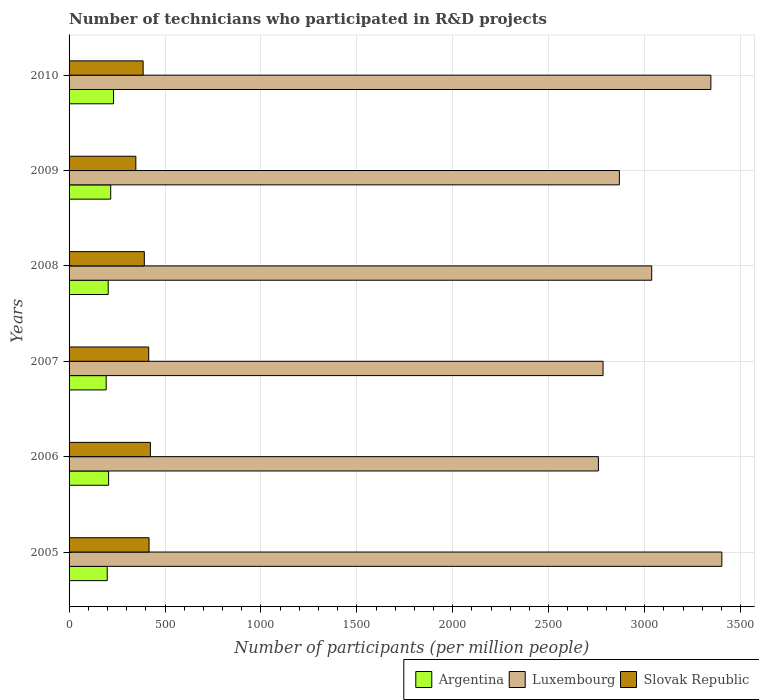How many different coloured bars are there?
Your answer should be compact. 3. Are the number of bars per tick equal to the number of legend labels?
Make the answer very short. Yes. Are the number of bars on each tick of the Y-axis equal?
Make the answer very short. Yes. How many bars are there on the 5th tick from the bottom?
Offer a very short reply. 3. What is the label of the 4th group of bars from the top?
Your response must be concise. 2007. In how many cases, is the number of bars for a given year not equal to the number of legend labels?
Provide a short and direct response. 0. What is the number of technicians who participated in R&D projects in Luxembourg in 2005?
Keep it short and to the point. 3402.45. Across all years, what is the maximum number of technicians who participated in R&D projects in Slovak Republic?
Offer a very short reply. 423.83. Across all years, what is the minimum number of technicians who participated in R&D projects in Argentina?
Give a very brief answer. 193.45. What is the total number of technicians who participated in R&D projects in Argentina in the graph?
Keep it short and to the point. 1250.98. What is the difference between the number of technicians who participated in R&D projects in Slovak Republic in 2005 and that in 2007?
Your answer should be very brief. 1.79. What is the difference between the number of technicians who participated in R&D projects in Argentina in 2005 and the number of technicians who participated in R&D projects in Luxembourg in 2007?
Ensure brevity in your answer.  -2584.25. What is the average number of technicians who participated in R&D projects in Luxembourg per year?
Ensure brevity in your answer.  3032.48. In the year 2009, what is the difference between the number of technicians who participated in R&D projects in Slovak Republic and number of technicians who participated in R&D projects in Argentina?
Ensure brevity in your answer.  131.09. In how many years, is the number of technicians who participated in R&D projects in Slovak Republic greater than 1500 ?
Your answer should be compact. 0. What is the ratio of the number of technicians who participated in R&D projects in Slovak Republic in 2005 to that in 2009?
Make the answer very short. 1.2. Is the difference between the number of technicians who participated in R&D projects in Slovak Republic in 2005 and 2009 greater than the difference between the number of technicians who participated in R&D projects in Argentina in 2005 and 2009?
Offer a very short reply. Yes. What is the difference between the highest and the second highest number of technicians who participated in R&D projects in Luxembourg?
Keep it short and to the point. 57.23. What is the difference between the highest and the lowest number of technicians who participated in R&D projects in Slovak Republic?
Your answer should be very brief. 75.77. What does the 1st bar from the top in 2006 represents?
Your response must be concise. Slovak Republic. What does the 1st bar from the bottom in 2007 represents?
Provide a succinct answer. Argentina. Are all the bars in the graph horizontal?
Keep it short and to the point. Yes. What is the difference between two consecutive major ticks on the X-axis?
Your answer should be very brief. 500. Are the values on the major ticks of X-axis written in scientific E-notation?
Your answer should be very brief. No. Does the graph contain any zero values?
Ensure brevity in your answer.  No. Does the graph contain grids?
Keep it short and to the point. Yes. What is the title of the graph?
Keep it short and to the point. Number of technicians who participated in R&D projects. What is the label or title of the X-axis?
Make the answer very short. Number of participants (per million people). What is the label or title of the Y-axis?
Provide a succinct answer. Years. What is the Number of participants (per million people) in Argentina in 2005?
Provide a succinct answer. 198.95. What is the Number of participants (per million people) in Luxembourg in 2005?
Offer a very short reply. 3402.45. What is the Number of participants (per million people) in Slovak Republic in 2005?
Keep it short and to the point. 416.85. What is the Number of participants (per million people) of Argentina in 2006?
Your response must be concise. 206.05. What is the Number of participants (per million people) of Luxembourg in 2006?
Your answer should be compact. 2758.91. What is the Number of participants (per million people) in Slovak Republic in 2006?
Make the answer very short. 423.83. What is the Number of participants (per million people) in Argentina in 2007?
Your answer should be compact. 193.45. What is the Number of participants (per million people) of Luxembourg in 2007?
Your answer should be compact. 2783.2. What is the Number of participants (per million people) of Slovak Republic in 2007?
Offer a very short reply. 415.06. What is the Number of participants (per million people) of Argentina in 2008?
Offer a very short reply. 203.95. What is the Number of participants (per million people) in Luxembourg in 2008?
Ensure brevity in your answer.  3036.82. What is the Number of participants (per million people) in Slovak Republic in 2008?
Offer a very short reply. 392.28. What is the Number of participants (per million people) in Argentina in 2009?
Your response must be concise. 216.97. What is the Number of participants (per million people) in Luxembourg in 2009?
Provide a succinct answer. 2868.27. What is the Number of participants (per million people) of Slovak Republic in 2009?
Ensure brevity in your answer.  348.06. What is the Number of participants (per million people) in Argentina in 2010?
Give a very brief answer. 231.62. What is the Number of participants (per million people) in Luxembourg in 2010?
Your response must be concise. 3345.22. What is the Number of participants (per million people) of Slovak Republic in 2010?
Your answer should be compact. 386.01. Across all years, what is the maximum Number of participants (per million people) in Argentina?
Provide a short and direct response. 231.62. Across all years, what is the maximum Number of participants (per million people) in Luxembourg?
Offer a very short reply. 3402.45. Across all years, what is the maximum Number of participants (per million people) of Slovak Republic?
Offer a very short reply. 423.83. Across all years, what is the minimum Number of participants (per million people) of Argentina?
Ensure brevity in your answer.  193.45. Across all years, what is the minimum Number of participants (per million people) of Luxembourg?
Your response must be concise. 2758.91. Across all years, what is the minimum Number of participants (per million people) of Slovak Republic?
Ensure brevity in your answer.  348.06. What is the total Number of participants (per million people) in Argentina in the graph?
Offer a terse response. 1250.98. What is the total Number of participants (per million people) in Luxembourg in the graph?
Provide a short and direct response. 1.82e+04. What is the total Number of participants (per million people) of Slovak Republic in the graph?
Give a very brief answer. 2382.08. What is the difference between the Number of participants (per million people) in Argentina in 2005 and that in 2006?
Your answer should be compact. -7.1. What is the difference between the Number of participants (per million people) of Luxembourg in 2005 and that in 2006?
Make the answer very short. 643.54. What is the difference between the Number of participants (per million people) in Slovak Republic in 2005 and that in 2006?
Offer a terse response. -6.99. What is the difference between the Number of participants (per million people) in Argentina in 2005 and that in 2007?
Offer a very short reply. 5.5. What is the difference between the Number of participants (per million people) of Luxembourg in 2005 and that in 2007?
Your answer should be very brief. 619.24. What is the difference between the Number of participants (per million people) in Slovak Republic in 2005 and that in 2007?
Ensure brevity in your answer.  1.79. What is the difference between the Number of participants (per million people) of Argentina in 2005 and that in 2008?
Offer a terse response. -5. What is the difference between the Number of participants (per million people) in Luxembourg in 2005 and that in 2008?
Your answer should be compact. 365.62. What is the difference between the Number of participants (per million people) of Slovak Republic in 2005 and that in 2008?
Your answer should be compact. 24.57. What is the difference between the Number of participants (per million people) of Argentina in 2005 and that in 2009?
Provide a short and direct response. -18.02. What is the difference between the Number of participants (per million people) of Luxembourg in 2005 and that in 2009?
Ensure brevity in your answer.  534.17. What is the difference between the Number of participants (per million people) of Slovak Republic in 2005 and that in 2009?
Provide a succinct answer. 68.79. What is the difference between the Number of participants (per million people) in Argentina in 2005 and that in 2010?
Your answer should be compact. -32.67. What is the difference between the Number of participants (per million people) of Luxembourg in 2005 and that in 2010?
Give a very brief answer. 57.23. What is the difference between the Number of participants (per million people) of Slovak Republic in 2005 and that in 2010?
Your answer should be very brief. 30.84. What is the difference between the Number of participants (per million people) in Argentina in 2006 and that in 2007?
Keep it short and to the point. 12.6. What is the difference between the Number of participants (per million people) in Luxembourg in 2006 and that in 2007?
Ensure brevity in your answer.  -24.29. What is the difference between the Number of participants (per million people) of Slovak Republic in 2006 and that in 2007?
Offer a terse response. 8.77. What is the difference between the Number of participants (per million people) in Argentina in 2006 and that in 2008?
Offer a terse response. 2.1. What is the difference between the Number of participants (per million people) of Luxembourg in 2006 and that in 2008?
Give a very brief answer. -277.91. What is the difference between the Number of participants (per million people) of Slovak Republic in 2006 and that in 2008?
Your answer should be compact. 31.56. What is the difference between the Number of participants (per million people) in Argentina in 2006 and that in 2009?
Ensure brevity in your answer.  -10.92. What is the difference between the Number of participants (per million people) in Luxembourg in 2006 and that in 2009?
Offer a terse response. -109.36. What is the difference between the Number of participants (per million people) of Slovak Republic in 2006 and that in 2009?
Keep it short and to the point. 75.77. What is the difference between the Number of participants (per million people) in Argentina in 2006 and that in 2010?
Provide a short and direct response. -25.57. What is the difference between the Number of participants (per million people) of Luxembourg in 2006 and that in 2010?
Make the answer very short. -586.31. What is the difference between the Number of participants (per million people) in Slovak Republic in 2006 and that in 2010?
Ensure brevity in your answer.  37.83. What is the difference between the Number of participants (per million people) of Argentina in 2007 and that in 2008?
Your answer should be compact. -10.51. What is the difference between the Number of participants (per million people) in Luxembourg in 2007 and that in 2008?
Your response must be concise. -253.62. What is the difference between the Number of participants (per million people) of Slovak Republic in 2007 and that in 2008?
Ensure brevity in your answer.  22.79. What is the difference between the Number of participants (per million people) in Argentina in 2007 and that in 2009?
Make the answer very short. -23.52. What is the difference between the Number of participants (per million people) in Luxembourg in 2007 and that in 2009?
Provide a succinct answer. -85.07. What is the difference between the Number of participants (per million people) of Slovak Republic in 2007 and that in 2009?
Make the answer very short. 67. What is the difference between the Number of participants (per million people) of Argentina in 2007 and that in 2010?
Your answer should be very brief. -38.17. What is the difference between the Number of participants (per million people) of Luxembourg in 2007 and that in 2010?
Ensure brevity in your answer.  -562.02. What is the difference between the Number of participants (per million people) of Slovak Republic in 2007 and that in 2010?
Ensure brevity in your answer.  29.05. What is the difference between the Number of participants (per million people) of Argentina in 2008 and that in 2009?
Provide a succinct answer. -13.02. What is the difference between the Number of participants (per million people) in Luxembourg in 2008 and that in 2009?
Provide a short and direct response. 168.55. What is the difference between the Number of participants (per million people) in Slovak Republic in 2008 and that in 2009?
Make the answer very short. 44.22. What is the difference between the Number of participants (per million people) in Argentina in 2008 and that in 2010?
Ensure brevity in your answer.  -27.67. What is the difference between the Number of participants (per million people) of Luxembourg in 2008 and that in 2010?
Ensure brevity in your answer.  -308.39. What is the difference between the Number of participants (per million people) of Slovak Republic in 2008 and that in 2010?
Offer a very short reply. 6.27. What is the difference between the Number of participants (per million people) of Argentina in 2009 and that in 2010?
Ensure brevity in your answer.  -14.65. What is the difference between the Number of participants (per million people) of Luxembourg in 2009 and that in 2010?
Give a very brief answer. -476.95. What is the difference between the Number of participants (per million people) of Slovak Republic in 2009 and that in 2010?
Your answer should be very brief. -37.95. What is the difference between the Number of participants (per million people) of Argentina in 2005 and the Number of participants (per million people) of Luxembourg in 2006?
Keep it short and to the point. -2559.96. What is the difference between the Number of participants (per million people) in Argentina in 2005 and the Number of participants (per million people) in Slovak Republic in 2006?
Ensure brevity in your answer.  -224.88. What is the difference between the Number of participants (per million people) of Luxembourg in 2005 and the Number of participants (per million people) of Slovak Republic in 2006?
Make the answer very short. 2978.61. What is the difference between the Number of participants (per million people) of Argentina in 2005 and the Number of participants (per million people) of Luxembourg in 2007?
Your response must be concise. -2584.25. What is the difference between the Number of participants (per million people) in Argentina in 2005 and the Number of participants (per million people) in Slovak Republic in 2007?
Your answer should be compact. -216.11. What is the difference between the Number of participants (per million people) in Luxembourg in 2005 and the Number of participants (per million people) in Slovak Republic in 2007?
Provide a short and direct response. 2987.38. What is the difference between the Number of participants (per million people) in Argentina in 2005 and the Number of participants (per million people) in Luxembourg in 2008?
Provide a succinct answer. -2837.87. What is the difference between the Number of participants (per million people) in Argentina in 2005 and the Number of participants (per million people) in Slovak Republic in 2008?
Your answer should be compact. -193.33. What is the difference between the Number of participants (per million people) of Luxembourg in 2005 and the Number of participants (per million people) of Slovak Republic in 2008?
Offer a terse response. 3010.17. What is the difference between the Number of participants (per million people) in Argentina in 2005 and the Number of participants (per million people) in Luxembourg in 2009?
Make the answer very short. -2669.32. What is the difference between the Number of participants (per million people) of Argentina in 2005 and the Number of participants (per million people) of Slovak Republic in 2009?
Keep it short and to the point. -149.11. What is the difference between the Number of participants (per million people) in Luxembourg in 2005 and the Number of participants (per million people) in Slovak Republic in 2009?
Provide a succinct answer. 3054.39. What is the difference between the Number of participants (per million people) in Argentina in 2005 and the Number of participants (per million people) in Luxembourg in 2010?
Your answer should be very brief. -3146.27. What is the difference between the Number of participants (per million people) in Argentina in 2005 and the Number of participants (per million people) in Slovak Republic in 2010?
Offer a very short reply. -187.06. What is the difference between the Number of participants (per million people) of Luxembourg in 2005 and the Number of participants (per million people) of Slovak Republic in 2010?
Ensure brevity in your answer.  3016.44. What is the difference between the Number of participants (per million people) in Argentina in 2006 and the Number of participants (per million people) in Luxembourg in 2007?
Provide a short and direct response. -2577.15. What is the difference between the Number of participants (per million people) of Argentina in 2006 and the Number of participants (per million people) of Slovak Republic in 2007?
Provide a succinct answer. -209.01. What is the difference between the Number of participants (per million people) of Luxembourg in 2006 and the Number of participants (per million people) of Slovak Republic in 2007?
Ensure brevity in your answer.  2343.85. What is the difference between the Number of participants (per million people) of Argentina in 2006 and the Number of participants (per million people) of Luxembourg in 2008?
Your response must be concise. -2830.78. What is the difference between the Number of participants (per million people) in Argentina in 2006 and the Number of participants (per million people) in Slovak Republic in 2008?
Provide a succinct answer. -186.23. What is the difference between the Number of participants (per million people) of Luxembourg in 2006 and the Number of participants (per million people) of Slovak Republic in 2008?
Make the answer very short. 2366.64. What is the difference between the Number of participants (per million people) in Argentina in 2006 and the Number of participants (per million people) in Luxembourg in 2009?
Offer a terse response. -2662.22. What is the difference between the Number of participants (per million people) in Argentina in 2006 and the Number of participants (per million people) in Slovak Republic in 2009?
Your response must be concise. -142.01. What is the difference between the Number of participants (per million people) in Luxembourg in 2006 and the Number of participants (per million people) in Slovak Republic in 2009?
Give a very brief answer. 2410.85. What is the difference between the Number of participants (per million people) of Argentina in 2006 and the Number of participants (per million people) of Luxembourg in 2010?
Your answer should be compact. -3139.17. What is the difference between the Number of participants (per million people) of Argentina in 2006 and the Number of participants (per million people) of Slovak Republic in 2010?
Your answer should be compact. -179.96. What is the difference between the Number of participants (per million people) in Luxembourg in 2006 and the Number of participants (per million people) in Slovak Republic in 2010?
Make the answer very short. 2372.9. What is the difference between the Number of participants (per million people) of Argentina in 2007 and the Number of participants (per million people) of Luxembourg in 2008?
Provide a short and direct response. -2843.38. What is the difference between the Number of participants (per million people) in Argentina in 2007 and the Number of participants (per million people) in Slovak Republic in 2008?
Your response must be concise. -198.83. What is the difference between the Number of participants (per million people) of Luxembourg in 2007 and the Number of participants (per million people) of Slovak Republic in 2008?
Your answer should be compact. 2390.93. What is the difference between the Number of participants (per million people) of Argentina in 2007 and the Number of participants (per million people) of Luxembourg in 2009?
Give a very brief answer. -2674.83. What is the difference between the Number of participants (per million people) of Argentina in 2007 and the Number of participants (per million people) of Slovak Republic in 2009?
Your answer should be very brief. -154.61. What is the difference between the Number of participants (per million people) of Luxembourg in 2007 and the Number of participants (per million people) of Slovak Republic in 2009?
Your response must be concise. 2435.14. What is the difference between the Number of participants (per million people) of Argentina in 2007 and the Number of participants (per million people) of Luxembourg in 2010?
Offer a very short reply. -3151.77. What is the difference between the Number of participants (per million people) of Argentina in 2007 and the Number of participants (per million people) of Slovak Republic in 2010?
Your answer should be very brief. -192.56. What is the difference between the Number of participants (per million people) in Luxembourg in 2007 and the Number of participants (per million people) in Slovak Republic in 2010?
Make the answer very short. 2397.2. What is the difference between the Number of participants (per million people) of Argentina in 2008 and the Number of participants (per million people) of Luxembourg in 2009?
Your answer should be very brief. -2664.32. What is the difference between the Number of participants (per million people) of Argentina in 2008 and the Number of participants (per million people) of Slovak Republic in 2009?
Ensure brevity in your answer.  -144.11. What is the difference between the Number of participants (per million people) of Luxembourg in 2008 and the Number of participants (per million people) of Slovak Republic in 2009?
Provide a succinct answer. 2688.77. What is the difference between the Number of participants (per million people) of Argentina in 2008 and the Number of participants (per million people) of Luxembourg in 2010?
Your answer should be compact. -3141.27. What is the difference between the Number of participants (per million people) in Argentina in 2008 and the Number of participants (per million people) in Slovak Republic in 2010?
Provide a short and direct response. -182.05. What is the difference between the Number of participants (per million people) of Luxembourg in 2008 and the Number of participants (per million people) of Slovak Republic in 2010?
Ensure brevity in your answer.  2650.82. What is the difference between the Number of participants (per million people) of Argentina in 2009 and the Number of participants (per million people) of Luxembourg in 2010?
Provide a short and direct response. -3128.25. What is the difference between the Number of participants (per million people) of Argentina in 2009 and the Number of participants (per million people) of Slovak Republic in 2010?
Your answer should be compact. -169.04. What is the difference between the Number of participants (per million people) of Luxembourg in 2009 and the Number of participants (per million people) of Slovak Republic in 2010?
Keep it short and to the point. 2482.26. What is the average Number of participants (per million people) of Argentina per year?
Keep it short and to the point. 208.5. What is the average Number of participants (per million people) in Luxembourg per year?
Ensure brevity in your answer.  3032.48. What is the average Number of participants (per million people) in Slovak Republic per year?
Provide a short and direct response. 397.01. In the year 2005, what is the difference between the Number of participants (per million people) in Argentina and Number of participants (per million people) in Luxembourg?
Ensure brevity in your answer.  -3203.5. In the year 2005, what is the difference between the Number of participants (per million people) in Argentina and Number of participants (per million people) in Slovak Republic?
Your response must be concise. -217.9. In the year 2005, what is the difference between the Number of participants (per million people) of Luxembourg and Number of participants (per million people) of Slovak Republic?
Offer a terse response. 2985.6. In the year 2006, what is the difference between the Number of participants (per million people) of Argentina and Number of participants (per million people) of Luxembourg?
Your answer should be very brief. -2552.86. In the year 2006, what is the difference between the Number of participants (per million people) in Argentina and Number of participants (per million people) in Slovak Republic?
Your answer should be compact. -217.79. In the year 2006, what is the difference between the Number of participants (per million people) in Luxembourg and Number of participants (per million people) in Slovak Republic?
Your answer should be compact. 2335.08. In the year 2007, what is the difference between the Number of participants (per million people) in Argentina and Number of participants (per million people) in Luxembourg?
Offer a terse response. -2589.76. In the year 2007, what is the difference between the Number of participants (per million people) in Argentina and Number of participants (per million people) in Slovak Republic?
Your answer should be very brief. -221.62. In the year 2007, what is the difference between the Number of participants (per million people) of Luxembourg and Number of participants (per million people) of Slovak Republic?
Ensure brevity in your answer.  2368.14. In the year 2008, what is the difference between the Number of participants (per million people) of Argentina and Number of participants (per million people) of Luxembourg?
Your answer should be very brief. -2832.87. In the year 2008, what is the difference between the Number of participants (per million people) of Argentina and Number of participants (per million people) of Slovak Republic?
Ensure brevity in your answer.  -188.32. In the year 2008, what is the difference between the Number of participants (per million people) in Luxembourg and Number of participants (per million people) in Slovak Republic?
Ensure brevity in your answer.  2644.55. In the year 2009, what is the difference between the Number of participants (per million people) of Argentina and Number of participants (per million people) of Luxembourg?
Provide a short and direct response. -2651.3. In the year 2009, what is the difference between the Number of participants (per million people) of Argentina and Number of participants (per million people) of Slovak Republic?
Offer a very short reply. -131.09. In the year 2009, what is the difference between the Number of participants (per million people) in Luxembourg and Number of participants (per million people) in Slovak Republic?
Provide a short and direct response. 2520.21. In the year 2010, what is the difference between the Number of participants (per million people) of Argentina and Number of participants (per million people) of Luxembourg?
Make the answer very short. -3113.6. In the year 2010, what is the difference between the Number of participants (per million people) of Argentina and Number of participants (per million people) of Slovak Republic?
Provide a succinct answer. -154.39. In the year 2010, what is the difference between the Number of participants (per million people) in Luxembourg and Number of participants (per million people) in Slovak Republic?
Keep it short and to the point. 2959.21. What is the ratio of the Number of participants (per million people) of Argentina in 2005 to that in 2006?
Provide a short and direct response. 0.97. What is the ratio of the Number of participants (per million people) of Luxembourg in 2005 to that in 2006?
Ensure brevity in your answer.  1.23. What is the ratio of the Number of participants (per million people) of Slovak Republic in 2005 to that in 2006?
Make the answer very short. 0.98. What is the ratio of the Number of participants (per million people) in Argentina in 2005 to that in 2007?
Provide a succinct answer. 1.03. What is the ratio of the Number of participants (per million people) in Luxembourg in 2005 to that in 2007?
Offer a very short reply. 1.22. What is the ratio of the Number of participants (per million people) of Slovak Republic in 2005 to that in 2007?
Provide a short and direct response. 1. What is the ratio of the Number of participants (per million people) in Argentina in 2005 to that in 2008?
Ensure brevity in your answer.  0.98. What is the ratio of the Number of participants (per million people) of Luxembourg in 2005 to that in 2008?
Your answer should be very brief. 1.12. What is the ratio of the Number of participants (per million people) of Slovak Republic in 2005 to that in 2008?
Your answer should be very brief. 1.06. What is the ratio of the Number of participants (per million people) of Argentina in 2005 to that in 2009?
Your answer should be very brief. 0.92. What is the ratio of the Number of participants (per million people) of Luxembourg in 2005 to that in 2009?
Keep it short and to the point. 1.19. What is the ratio of the Number of participants (per million people) of Slovak Republic in 2005 to that in 2009?
Provide a short and direct response. 1.2. What is the ratio of the Number of participants (per million people) of Argentina in 2005 to that in 2010?
Your response must be concise. 0.86. What is the ratio of the Number of participants (per million people) of Luxembourg in 2005 to that in 2010?
Provide a short and direct response. 1.02. What is the ratio of the Number of participants (per million people) in Slovak Republic in 2005 to that in 2010?
Keep it short and to the point. 1.08. What is the ratio of the Number of participants (per million people) in Argentina in 2006 to that in 2007?
Offer a very short reply. 1.07. What is the ratio of the Number of participants (per million people) of Luxembourg in 2006 to that in 2007?
Make the answer very short. 0.99. What is the ratio of the Number of participants (per million people) of Slovak Republic in 2006 to that in 2007?
Your response must be concise. 1.02. What is the ratio of the Number of participants (per million people) of Argentina in 2006 to that in 2008?
Make the answer very short. 1.01. What is the ratio of the Number of participants (per million people) in Luxembourg in 2006 to that in 2008?
Your answer should be compact. 0.91. What is the ratio of the Number of participants (per million people) of Slovak Republic in 2006 to that in 2008?
Make the answer very short. 1.08. What is the ratio of the Number of participants (per million people) of Argentina in 2006 to that in 2009?
Your answer should be compact. 0.95. What is the ratio of the Number of participants (per million people) of Luxembourg in 2006 to that in 2009?
Ensure brevity in your answer.  0.96. What is the ratio of the Number of participants (per million people) of Slovak Republic in 2006 to that in 2009?
Provide a succinct answer. 1.22. What is the ratio of the Number of participants (per million people) of Argentina in 2006 to that in 2010?
Provide a short and direct response. 0.89. What is the ratio of the Number of participants (per million people) in Luxembourg in 2006 to that in 2010?
Make the answer very short. 0.82. What is the ratio of the Number of participants (per million people) of Slovak Republic in 2006 to that in 2010?
Provide a succinct answer. 1.1. What is the ratio of the Number of participants (per million people) in Argentina in 2007 to that in 2008?
Your response must be concise. 0.95. What is the ratio of the Number of participants (per million people) of Luxembourg in 2007 to that in 2008?
Your answer should be compact. 0.92. What is the ratio of the Number of participants (per million people) of Slovak Republic in 2007 to that in 2008?
Keep it short and to the point. 1.06. What is the ratio of the Number of participants (per million people) of Argentina in 2007 to that in 2009?
Offer a terse response. 0.89. What is the ratio of the Number of participants (per million people) of Luxembourg in 2007 to that in 2009?
Ensure brevity in your answer.  0.97. What is the ratio of the Number of participants (per million people) of Slovak Republic in 2007 to that in 2009?
Your answer should be compact. 1.19. What is the ratio of the Number of participants (per million people) in Argentina in 2007 to that in 2010?
Make the answer very short. 0.84. What is the ratio of the Number of participants (per million people) in Luxembourg in 2007 to that in 2010?
Ensure brevity in your answer.  0.83. What is the ratio of the Number of participants (per million people) in Slovak Republic in 2007 to that in 2010?
Offer a terse response. 1.08. What is the ratio of the Number of participants (per million people) in Argentina in 2008 to that in 2009?
Ensure brevity in your answer.  0.94. What is the ratio of the Number of participants (per million people) of Luxembourg in 2008 to that in 2009?
Keep it short and to the point. 1.06. What is the ratio of the Number of participants (per million people) of Slovak Republic in 2008 to that in 2009?
Make the answer very short. 1.13. What is the ratio of the Number of participants (per million people) in Argentina in 2008 to that in 2010?
Keep it short and to the point. 0.88. What is the ratio of the Number of participants (per million people) in Luxembourg in 2008 to that in 2010?
Offer a terse response. 0.91. What is the ratio of the Number of participants (per million people) of Slovak Republic in 2008 to that in 2010?
Your response must be concise. 1.02. What is the ratio of the Number of participants (per million people) in Argentina in 2009 to that in 2010?
Ensure brevity in your answer.  0.94. What is the ratio of the Number of participants (per million people) of Luxembourg in 2009 to that in 2010?
Your answer should be compact. 0.86. What is the ratio of the Number of participants (per million people) in Slovak Republic in 2009 to that in 2010?
Your response must be concise. 0.9. What is the difference between the highest and the second highest Number of participants (per million people) in Argentina?
Your answer should be very brief. 14.65. What is the difference between the highest and the second highest Number of participants (per million people) of Luxembourg?
Your answer should be very brief. 57.23. What is the difference between the highest and the second highest Number of participants (per million people) in Slovak Republic?
Your answer should be compact. 6.99. What is the difference between the highest and the lowest Number of participants (per million people) in Argentina?
Your answer should be compact. 38.17. What is the difference between the highest and the lowest Number of participants (per million people) of Luxembourg?
Make the answer very short. 643.54. What is the difference between the highest and the lowest Number of participants (per million people) in Slovak Republic?
Offer a very short reply. 75.77. 